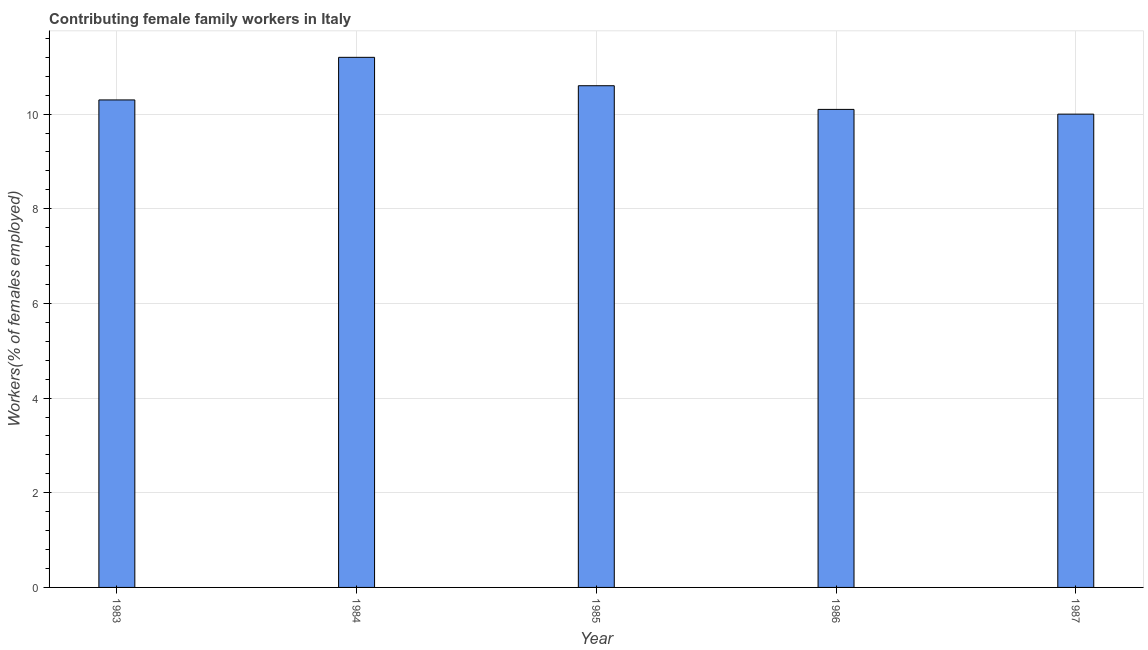Does the graph contain any zero values?
Offer a terse response. No. What is the title of the graph?
Make the answer very short. Contributing female family workers in Italy. What is the label or title of the Y-axis?
Offer a very short reply. Workers(% of females employed). What is the contributing female family workers in 1983?
Give a very brief answer. 10.3. Across all years, what is the maximum contributing female family workers?
Your answer should be compact. 11.2. In which year was the contributing female family workers minimum?
Give a very brief answer. 1987. What is the sum of the contributing female family workers?
Your response must be concise. 52.2. What is the average contributing female family workers per year?
Your response must be concise. 10.44. What is the median contributing female family workers?
Offer a terse response. 10.3. In how many years, is the contributing female family workers greater than 3.6 %?
Give a very brief answer. 5. Do a majority of the years between 1984 and 1983 (inclusive) have contributing female family workers greater than 10 %?
Your answer should be compact. No. What is the ratio of the contributing female family workers in 1984 to that in 1987?
Ensure brevity in your answer.  1.12. Is the contributing female family workers in 1985 less than that in 1986?
Offer a terse response. No. How many bars are there?
Give a very brief answer. 5. Are all the bars in the graph horizontal?
Give a very brief answer. No. What is the difference between two consecutive major ticks on the Y-axis?
Your response must be concise. 2. Are the values on the major ticks of Y-axis written in scientific E-notation?
Give a very brief answer. No. What is the Workers(% of females employed) of 1983?
Offer a very short reply. 10.3. What is the Workers(% of females employed) in 1984?
Keep it short and to the point. 11.2. What is the Workers(% of females employed) in 1985?
Ensure brevity in your answer.  10.6. What is the Workers(% of females employed) of 1986?
Give a very brief answer. 10.1. What is the difference between the Workers(% of females employed) in 1983 and 1985?
Your answer should be very brief. -0.3. What is the difference between the Workers(% of females employed) in 1983 and 1986?
Offer a terse response. 0.2. What is the difference between the Workers(% of females employed) in 1984 and 1986?
Give a very brief answer. 1.1. What is the difference between the Workers(% of females employed) in 1984 and 1987?
Your answer should be very brief. 1.2. What is the difference between the Workers(% of females employed) in 1985 and 1986?
Offer a very short reply. 0.5. What is the difference between the Workers(% of females employed) in 1986 and 1987?
Provide a short and direct response. 0.1. What is the ratio of the Workers(% of females employed) in 1983 to that in 1985?
Give a very brief answer. 0.97. What is the ratio of the Workers(% of females employed) in 1983 to that in 1986?
Keep it short and to the point. 1.02. What is the ratio of the Workers(% of females employed) in 1984 to that in 1985?
Provide a short and direct response. 1.06. What is the ratio of the Workers(% of females employed) in 1984 to that in 1986?
Give a very brief answer. 1.11. What is the ratio of the Workers(% of females employed) in 1984 to that in 1987?
Ensure brevity in your answer.  1.12. What is the ratio of the Workers(% of females employed) in 1985 to that in 1987?
Make the answer very short. 1.06. What is the ratio of the Workers(% of females employed) in 1986 to that in 1987?
Offer a terse response. 1.01. 